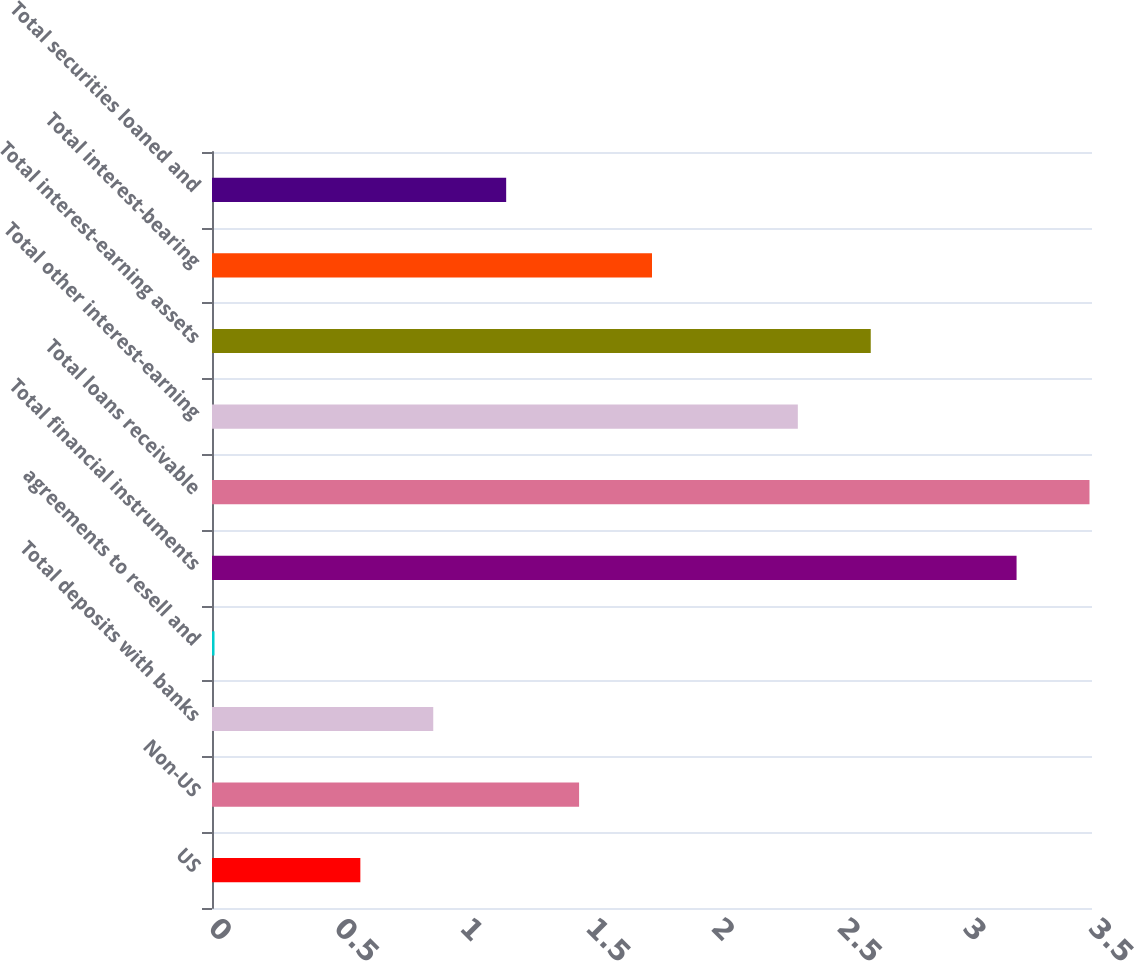Convert chart to OTSL. <chart><loc_0><loc_0><loc_500><loc_500><bar_chart><fcel>US<fcel>Non-US<fcel>Total deposits with banks<fcel>agreements to resell and<fcel>Total financial instruments<fcel>Total loans receivable<fcel>Total other interest-earning<fcel>Total interest-earning assets<fcel>Total interest-bearing<fcel>Total securities loaned and<nl><fcel>0.59<fcel>1.46<fcel>0.88<fcel>0.01<fcel>3.2<fcel>3.49<fcel>2.33<fcel>2.62<fcel>1.75<fcel>1.17<nl></chart> 